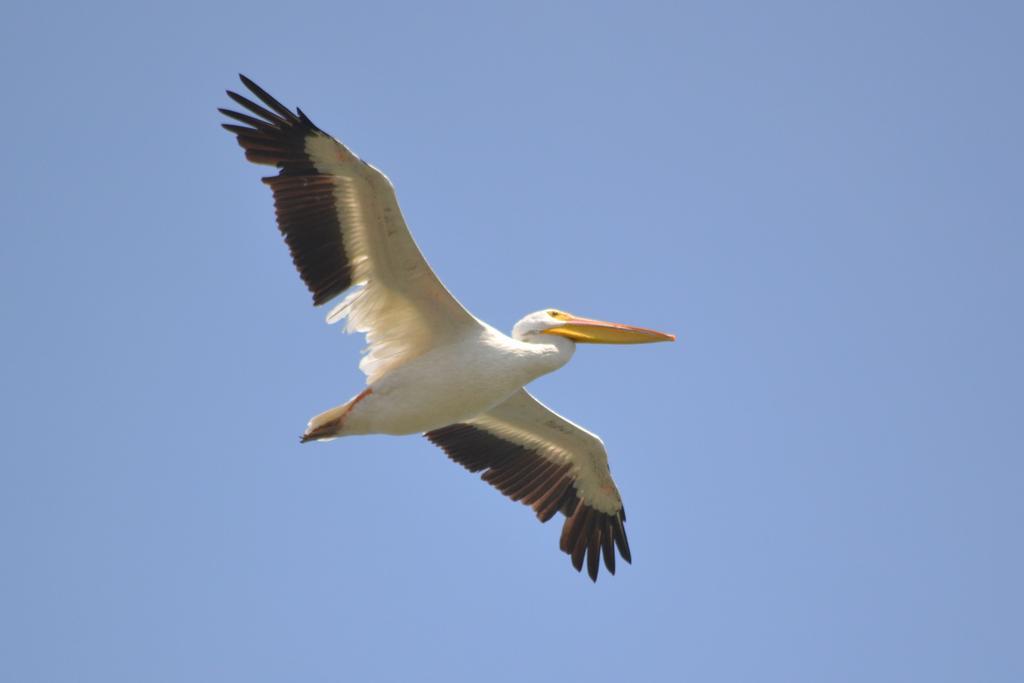Please provide a concise description of this image. In this picture we can see a bird is flying in the sky. 